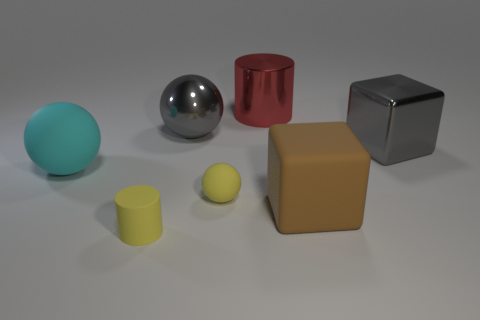How many red matte objects have the same size as the brown cube?
Provide a succinct answer. 0. Does the brown thing have the same size as the cylinder in front of the red metal object?
Offer a very short reply. No. What number of things are yellow rubber cylinders or big cyan metallic objects?
Ensure brevity in your answer.  1. How many other tiny rubber balls are the same color as the tiny rubber ball?
Offer a very short reply. 0. The red thing that is the same size as the gray shiny cube is what shape?
Give a very brief answer. Cylinder. Are there any small red metal objects that have the same shape as the big cyan matte thing?
Offer a very short reply. No. What number of other objects are the same material as the brown thing?
Ensure brevity in your answer.  3. Is the sphere that is left of the large gray shiny sphere made of the same material as the yellow cylinder?
Your answer should be very brief. Yes. Is the number of big cyan matte objects in front of the big red metallic cylinder greater than the number of rubber spheres in front of the tiny yellow matte ball?
Ensure brevity in your answer.  Yes. There is a ball that is the same size as the rubber cylinder; what is it made of?
Your answer should be compact. Rubber. 